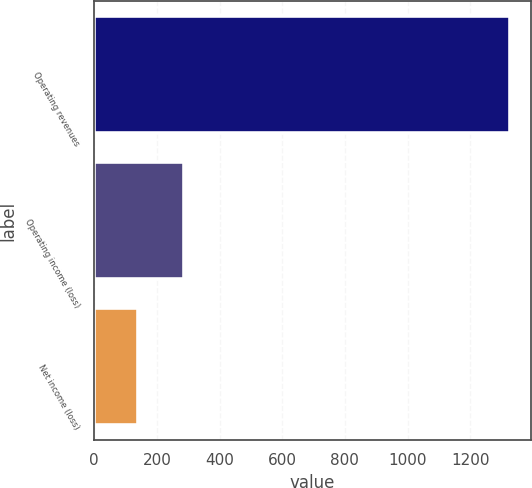Convert chart. <chart><loc_0><loc_0><loc_500><loc_500><bar_chart><fcel>Operating revenues<fcel>Operating income (loss)<fcel>Net income (loss)<nl><fcel>1328<fcel>286<fcel>139<nl></chart> 